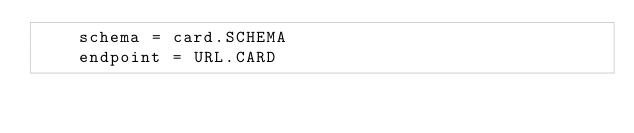<code> <loc_0><loc_0><loc_500><loc_500><_Python_>    schema = card.SCHEMA
    endpoint = URL.CARD
</code> 